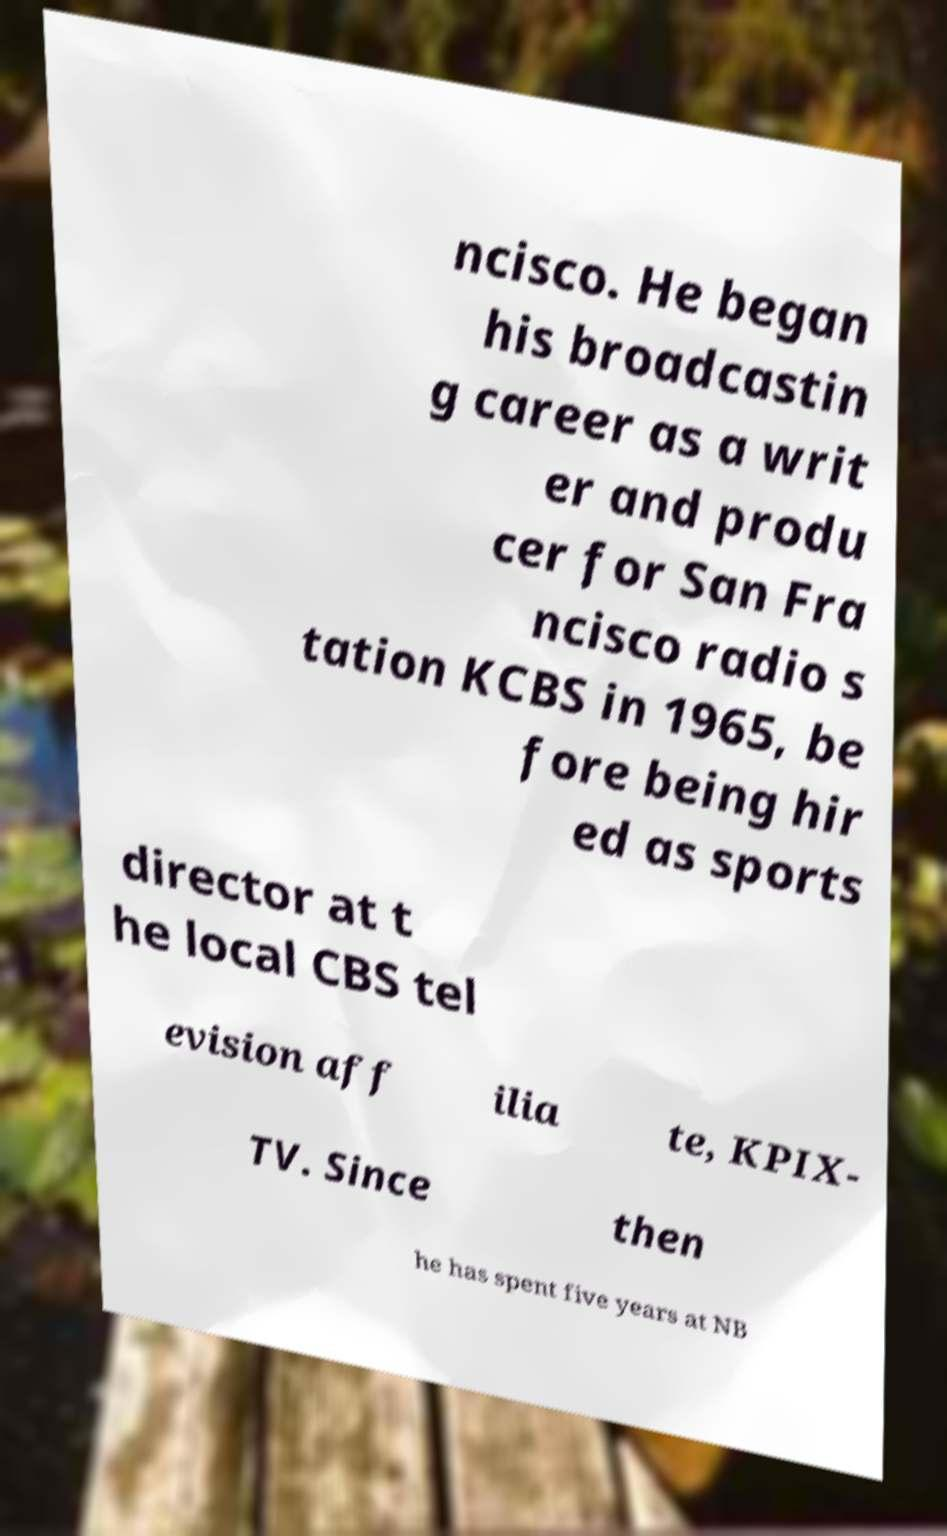I need the written content from this picture converted into text. Can you do that? ncisco. He began his broadcastin g career as a writ er and produ cer for San Fra ncisco radio s tation KCBS in 1965, be fore being hir ed as sports director at t he local CBS tel evision aff ilia te, KPIX- TV. Since then he has spent five years at NB 